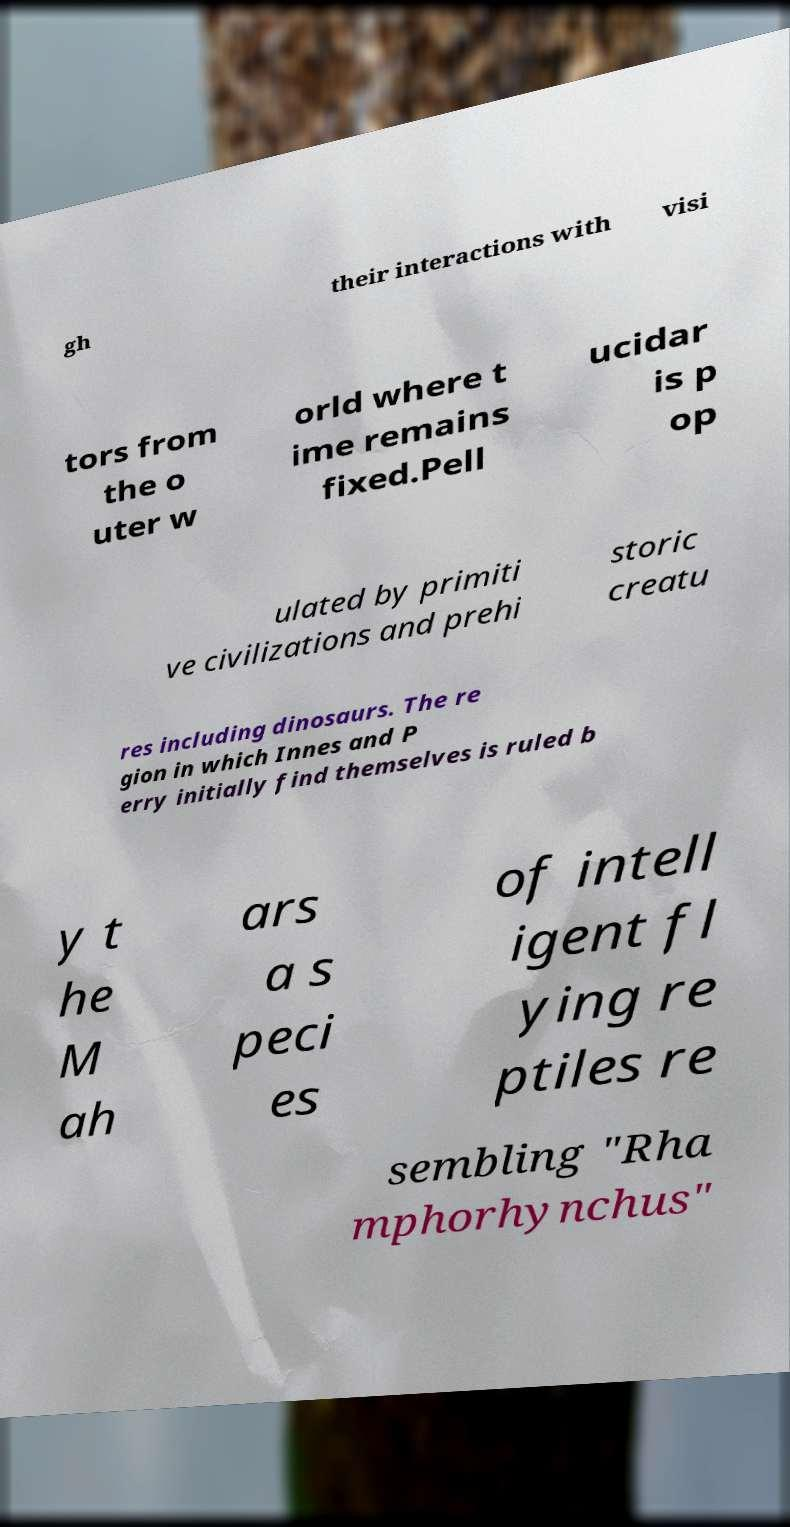Please identify and transcribe the text found in this image. gh their interactions with visi tors from the o uter w orld where t ime remains fixed.Pell ucidar is p op ulated by primiti ve civilizations and prehi storic creatu res including dinosaurs. The re gion in which Innes and P erry initially find themselves is ruled b y t he M ah ars a s peci es of intell igent fl ying re ptiles re sembling "Rha mphorhynchus" 